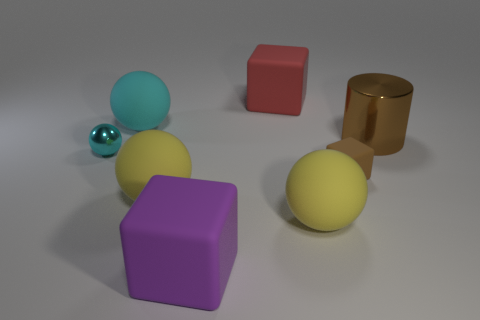Subtract all gray cylinders. Subtract all red spheres. How many cylinders are left? 1 Add 2 large red matte spheres. How many objects exist? 10 Subtract all cylinders. How many objects are left? 7 Subtract all red matte objects. Subtract all small matte objects. How many objects are left? 6 Add 4 small brown matte objects. How many small brown matte objects are left? 5 Add 1 small red cylinders. How many small red cylinders exist? 1 Subtract 0 red cylinders. How many objects are left? 8 